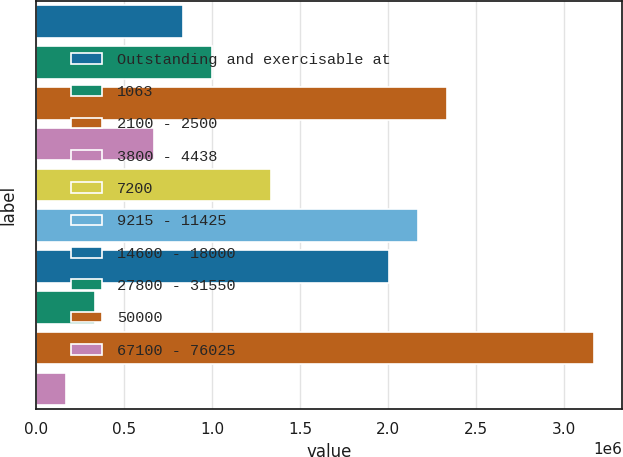<chart> <loc_0><loc_0><loc_500><loc_500><bar_chart><fcel>Outstanding and exercisable at<fcel>1063<fcel>2100 - 2500<fcel>3800 - 4438<fcel>7200<fcel>9215 - 11425<fcel>14600 - 18000<fcel>27800 - 31550<fcel>50000<fcel>67100 - 76025<nl><fcel>835262<fcel>1.00204e+06<fcel>2.33626e+06<fcel>668485<fcel>1.3356e+06<fcel>2.16948e+06<fcel>2.0027e+06<fcel>334930<fcel>3.17015e+06<fcel>168152<nl></chart> 